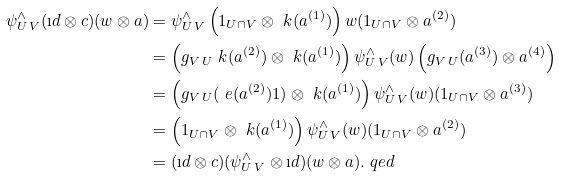<formula> <loc_0><loc_0><loc_500><loc_500>\psi _ { U \, V } ^ { \wedge } ( \i d \otimes c ) ( w \otimes a ) & = \psi _ { U \, V } ^ { \wedge } \left ( 1 _ { U \cap V } \otimes \ k ( a ^ { ( 1 ) } ) \right ) w ( 1 _ { U \cap V } \otimes a ^ { ( 2 ) } ) \\ & = \left ( g _ { V \, U } \ k ( a ^ { ( 2 ) } ) \otimes \ k ( a ^ { ( 1 ) } ) \right ) \psi _ { U \, V } ^ { \wedge } ( w ) \left ( g _ { V \, U } ( a ^ { ( 3 ) } ) \otimes a ^ { ( 4 ) } \right ) \\ & = \left ( g _ { V \, U } ( \ e ( a ^ { ( 2 ) } ) 1 ) \otimes \ k ( a ^ { ( 1 ) } ) \right ) \psi _ { U \, V } ^ { \wedge } ( w ) ( 1 _ { U \cap V } \otimes a ^ { ( 3 ) } ) \\ & = \left ( 1 _ { U \cap V } \otimes \ k ( a ^ { ( 1 ) } ) \right ) \psi _ { U \, V } ^ { \wedge } ( w ) ( 1 _ { U \cap V } \otimes a ^ { ( 2 ) } ) \\ & = ( \i d \otimes c ) ( \psi _ { U \, V } ^ { \wedge } \otimes \i d ) ( w \otimes a ) . \ q e d</formula> 